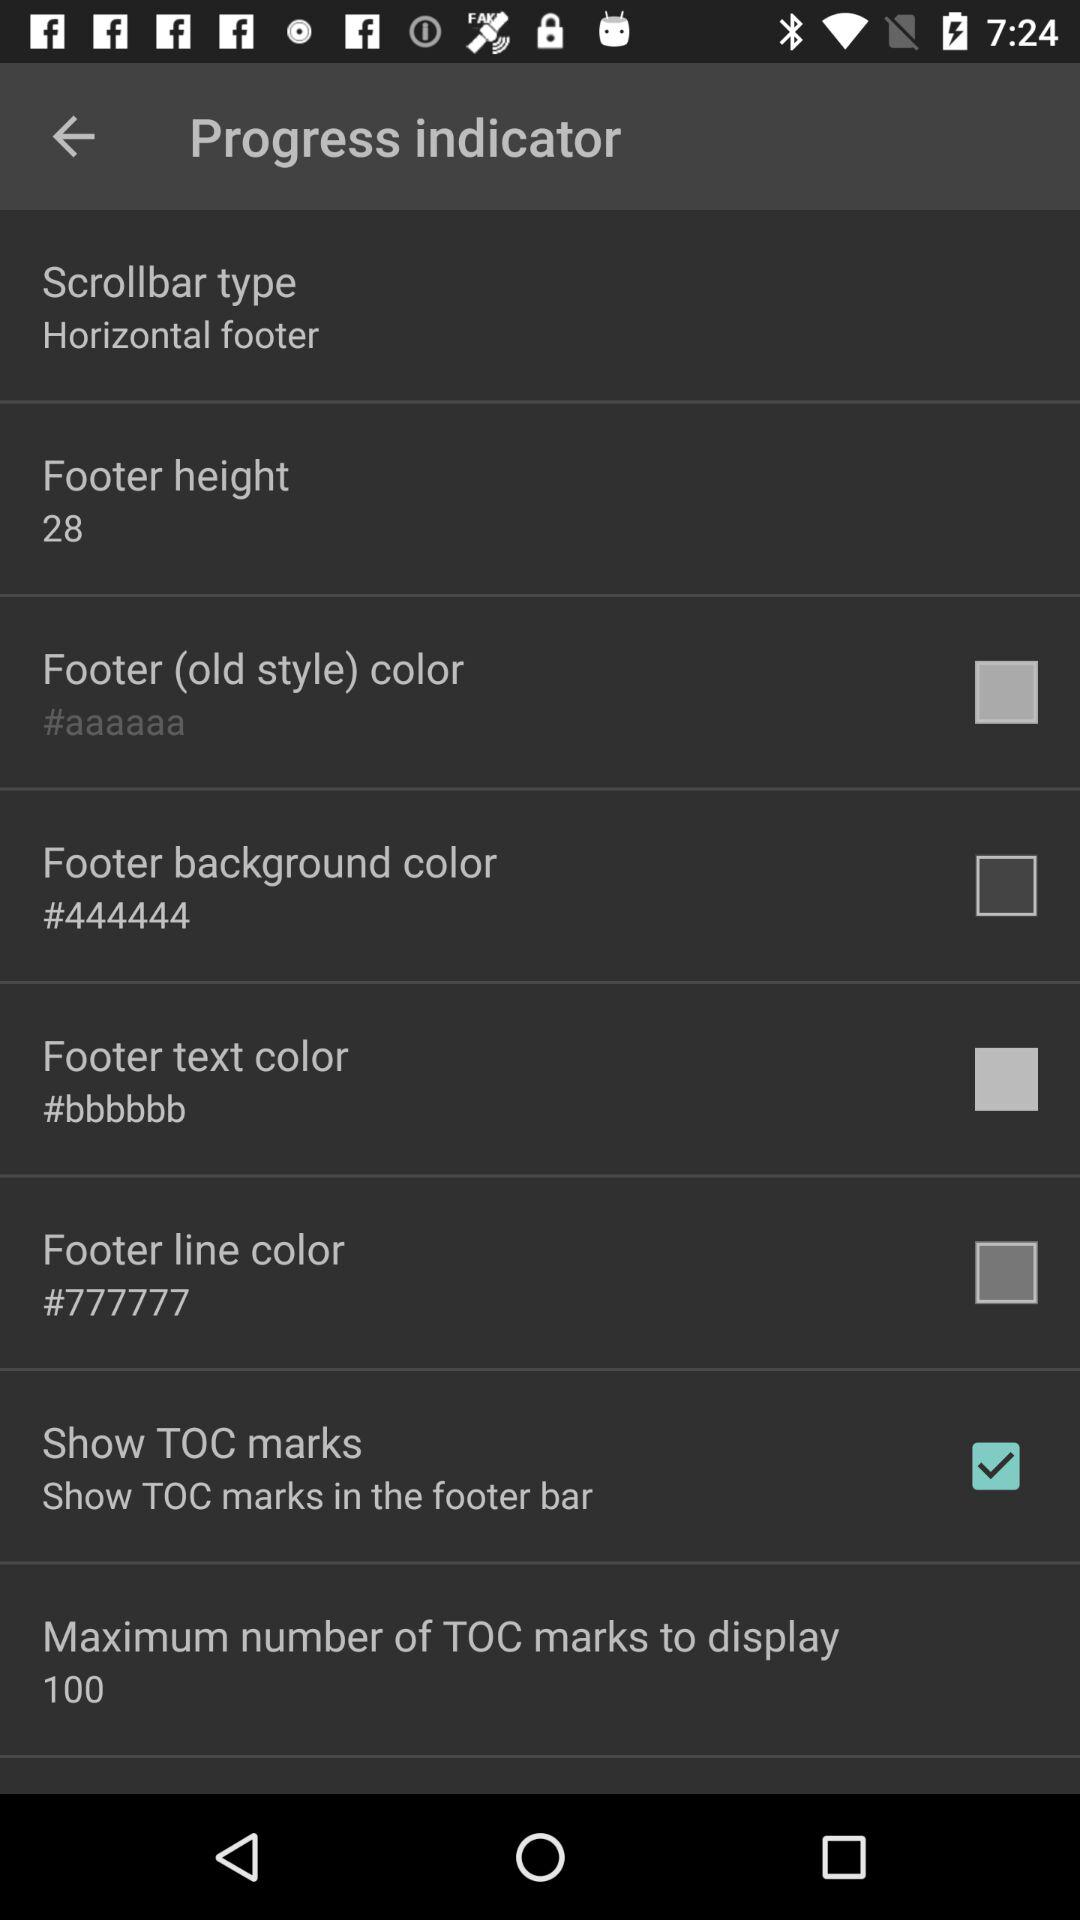What is the footer height? The footer height is 28. 